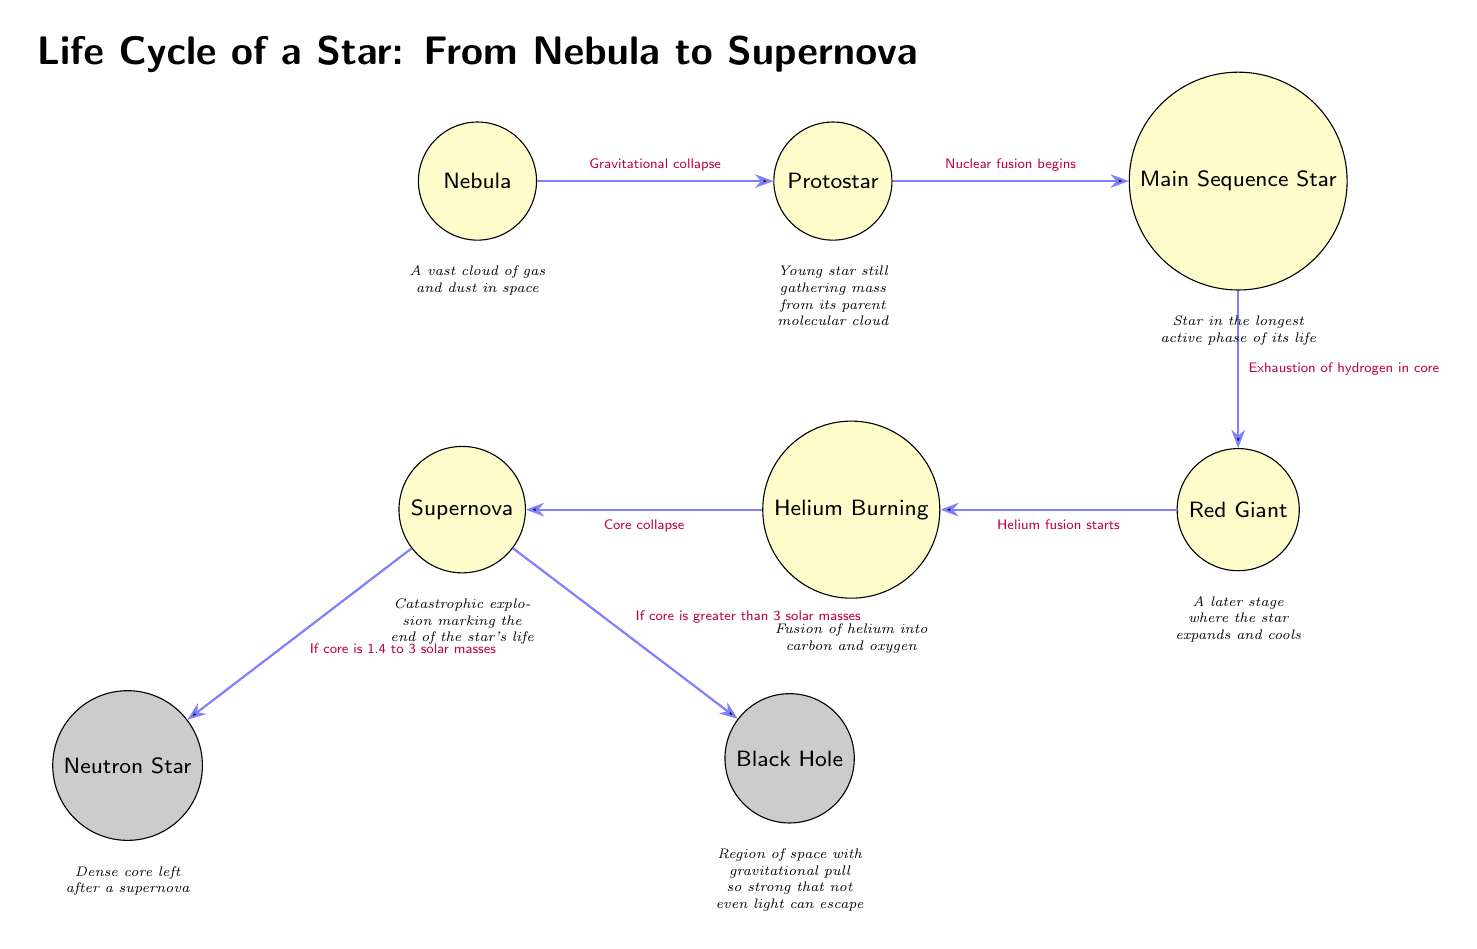What is the first stage in the life cycle of a star? The diagram shows "Nebula" as the first node on the left, indicating it is the starting stage of a star's life cycle.
Answer: Nebula How many end nodes are present in the diagram? There are two end nodes labeled "Neutron Star" and "Black Hole" located below the "Supernova" node, giving a total of two end nodes.
Answer: 2 What triggers the transition from "Protostar" to "Main Sequence Star"? The transition from "Protostar" to "Main Sequence Star" is triggered by "Nuclear fusion begins," which is indicated on the edge connecting these two nodes.
Answer: Nuclear fusion begins What happens after a star reaches the "Red Giant" stage? After "Red Giant," the star undergoes "Helium fusion starts," which is shown as the next step in the life cycle.
Answer: Helium fusion starts If a star's core is greater than 3 solar masses, what is the result of the supernova? According to the diagram, if the star's core is greater than 3 solar masses, the result is a "Black Hole" as indicated by the edge transitioning from the "Supernova" node.
Answer: Black Hole What is the function of the node labeled "Helium Burning"? The "Helium Burning" node represents a stage where the fusion of helium into carbon and oxygen occurs, as described in the explanation below this node in the diagram.
Answer: Fusion of helium into carbon and oxygen Which node represents the longest active phase of a star’s life? The "Main Sequence Star" node represents the longest active phase, as it is placed directly after "Protostar" and is identified specifically for this purpose in the diagram.
Answer: Main Sequence Star What event is illustrated by the transition from "Red Giant" to "Helium Burning"? The event illustrated is "Helium fusion starts," which signifies the beginning of fusion processes involving helium after the red giant phase.
Answer: Helium fusion starts What type of celestial event concludes the life of a star? The diagram indicates that the life of a star concludes with a "Supernova," which is marked as a significant event before potentially forming either a neutron star or black hole.
Answer: Supernova 